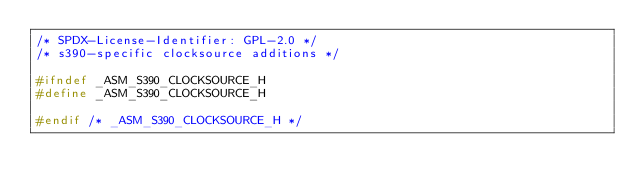<code> <loc_0><loc_0><loc_500><loc_500><_C_>/* SPDX-License-Identifier: GPL-2.0 */
/* s390-specific clocksource additions */

#ifndef _ASM_S390_CLOCKSOURCE_H
#define _ASM_S390_CLOCKSOURCE_H

#endif /* _ASM_S390_CLOCKSOURCE_H */
</code> 